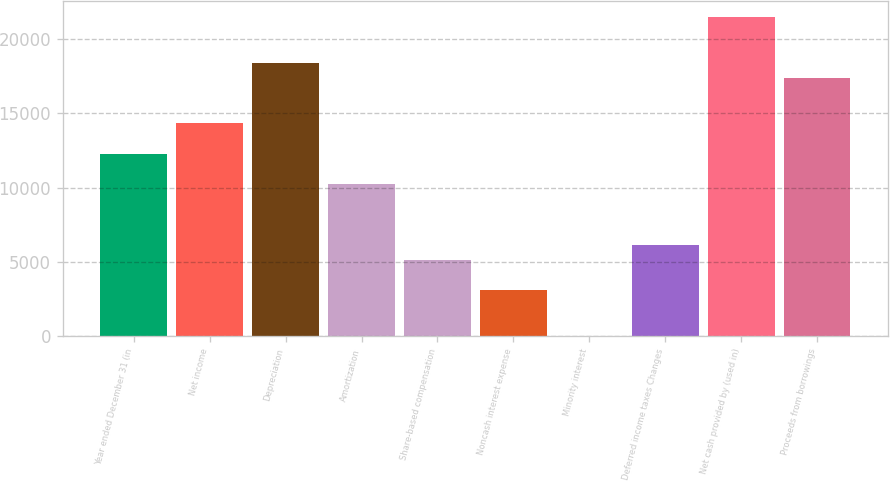Convert chart to OTSL. <chart><loc_0><loc_0><loc_500><loc_500><bar_chart><fcel>Year ended December 31 (in<fcel>Net income<fcel>Depreciation<fcel>Amortization<fcel>Share-based compensation<fcel>Noncash interest expense<fcel>Minority interest<fcel>Deferred income taxes Changes<fcel>Net cash provided by (used in)<fcel>Proceeds from borrowings<nl><fcel>12272.8<fcel>14314.6<fcel>18398.2<fcel>10231<fcel>5126.5<fcel>3084.7<fcel>22<fcel>6147.4<fcel>21460.9<fcel>17377.3<nl></chart> 